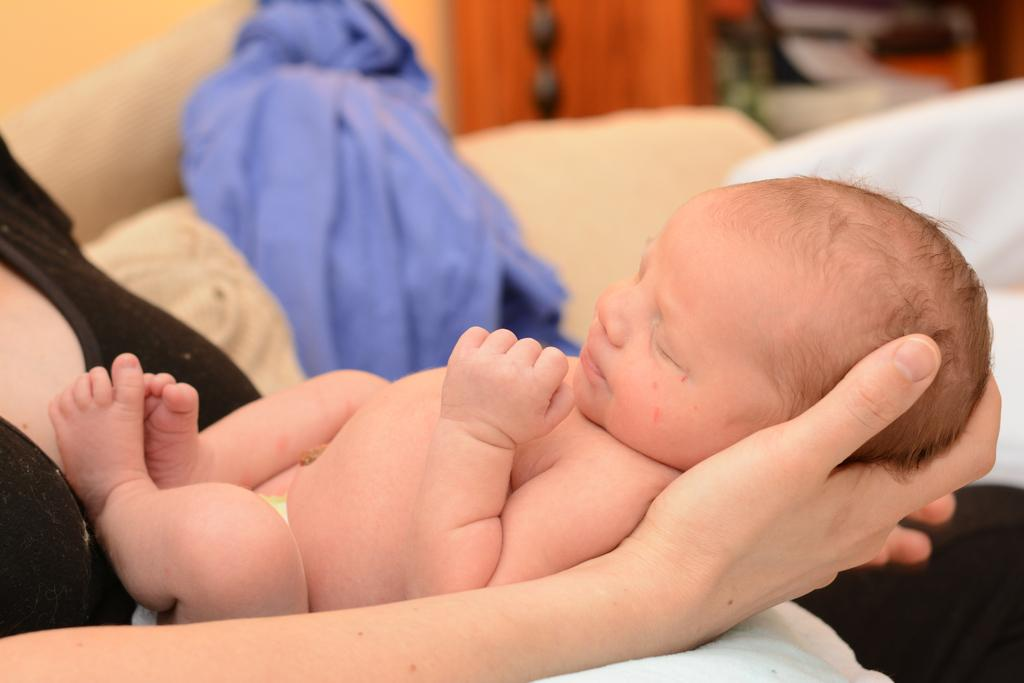Who is the main subject in the image? There is a woman in the image. What is the woman wearing? The woman is wearing a black dress. What is the woman doing in the image? The woman is holding a kid and sitting on a couch. What can be seen in the background of the image? There is a blue cloth in the background of the image. What is the woman's belief about the quiet trail in the image? There is no mention of a trail or any beliefs in the image; it features a woman holding a kid while sitting on a couch. 